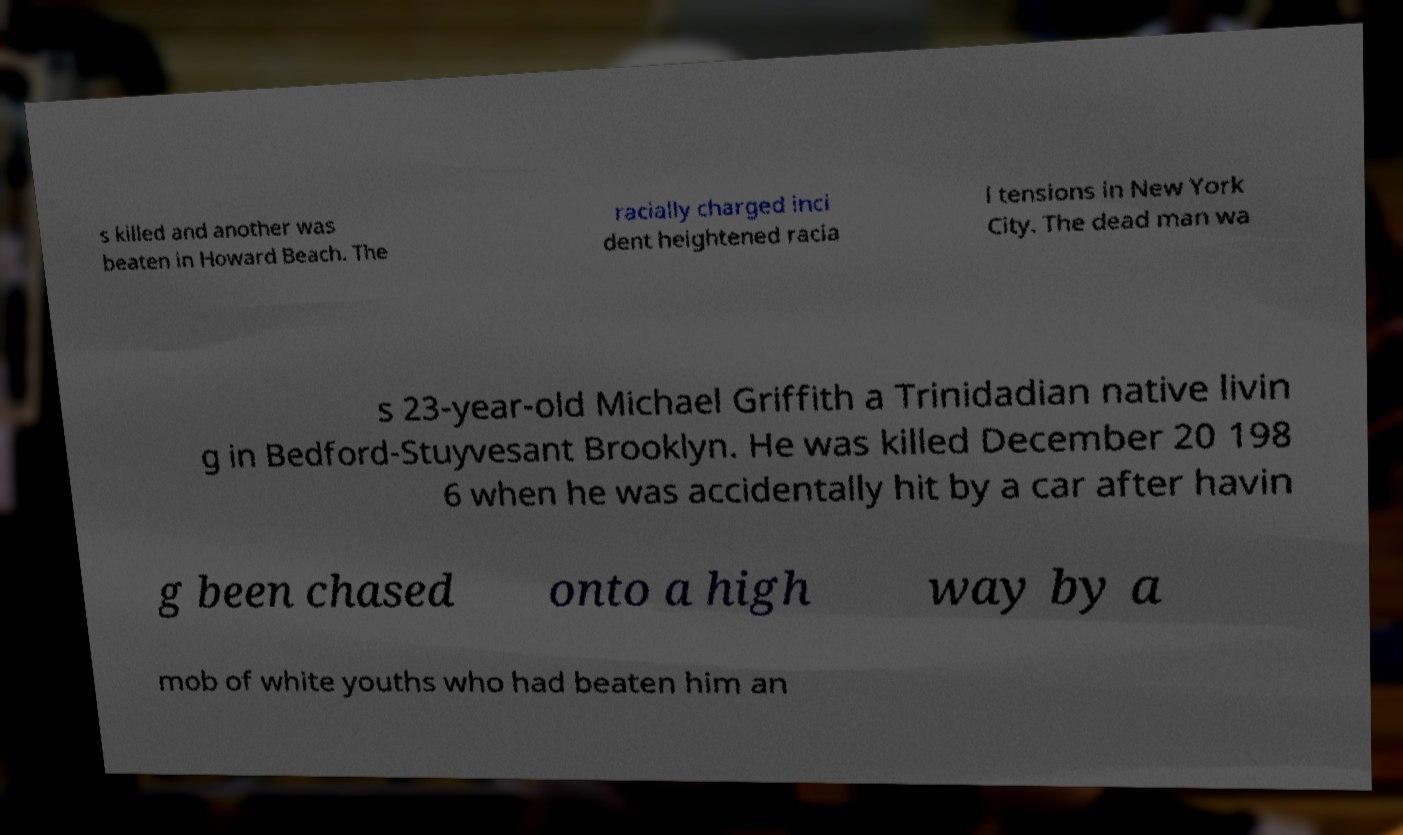For documentation purposes, I need the text within this image transcribed. Could you provide that? s killed and another was beaten in Howard Beach. The racially charged inci dent heightened racia l tensions in New York City. The dead man wa s 23-year-old Michael Griffith a Trinidadian native livin g in Bedford-Stuyvesant Brooklyn. He was killed December 20 198 6 when he was accidentally hit by a car after havin g been chased onto a high way by a mob of white youths who had beaten him an 